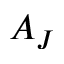<formula> <loc_0><loc_0><loc_500><loc_500>A _ { J }</formula> 